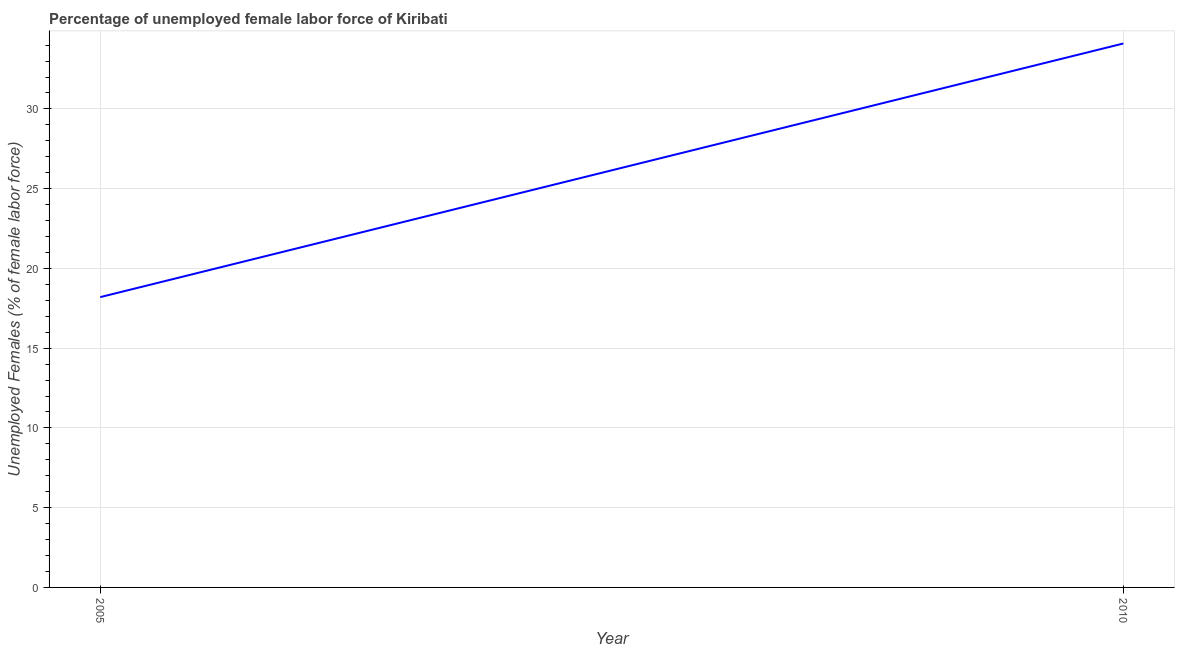What is the total unemployed female labour force in 2010?
Ensure brevity in your answer.  34.1. Across all years, what is the maximum total unemployed female labour force?
Ensure brevity in your answer.  34.1. Across all years, what is the minimum total unemployed female labour force?
Make the answer very short. 18.2. In which year was the total unemployed female labour force maximum?
Make the answer very short. 2010. In which year was the total unemployed female labour force minimum?
Offer a terse response. 2005. What is the sum of the total unemployed female labour force?
Offer a terse response. 52.3. What is the difference between the total unemployed female labour force in 2005 and 2010?
Ensure brevity in your answer.  -15.9. What is the average total unemployed female labour force per year?
Your answer should be very brief. 26.15. What is the median total unemployed female labour force?
Provide a short and direct response. 26.15. In how many years, is the total unemployed female labour force greater than 20 %?
Give a very brief answer. 1. What is the ratio of the total unemployed female labour force in 2005 to that in 2010?
Offer a very short reply. 0.53. How many lines are there?
Your answer should be very brief. 1. What is the title of the graph?
Ensure brevity in your answer.  Percentage of unemployed female labor force of Kiribati. What is the label or title of the X-axis?
Give a very brief answer. Year. What is the label or title of the Y-axis?
Make the answer very short. Unemployed Females (% of female labor force). What is the Unemployed Females (% of female labor force) in 2005?
Provide a succinct answer. 18.2. What is the Unemployed Females (% of female labor force) of 2010?
Your answer should be compact. 34.1. What is the difference between the Unemployed Females (% of female labor force) in 2005 and 2010?
Provide a short and direct response. -15.9. What is the ratio of the Unemployed Females (% of female labor force) in 2005 to that in 2010?
Your answer should be compact. 0.53. 